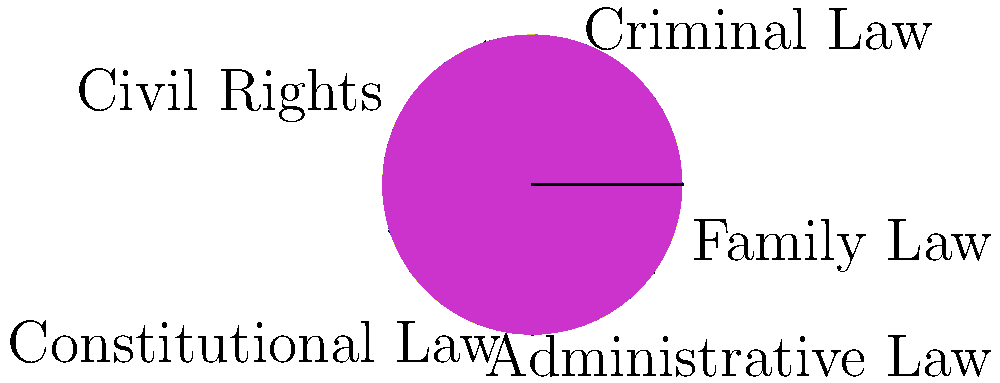Based on the pie chart depicting a judge's decisions across various legal domains, which area of law accounts for the largest portion of the judge's rulings, and what percentage does it represent? To answer this question, we need to analyze the pie chart and follow these steps:

1. Identify all the legal domains represented in the chart:
   - Criminal Law
   - Civil Rights
   - Constitutional Law
   - Administrative Law
   - Family Law

2. Visually compare the sizes of the slices to determine the largest one:
   The red slice, which represents Criminal Law, appears to be the largest.

3. Estimate the percentage of the largest slice:
   The pie chart is divided into 5 slices, with the largest (red) slice appearing to cover slightly less than one-third of the circle.

4. Calculate the exact percentage:
   The question provides the exact percentages in the data array:
   $${30, 25, 20, 15, 10}$$
   The largest value is 30, which corresponds to Criminal Law.

5. Confirm the result:
   Criminal Law accounts for 30% of the judge's decisions, which is indeed the largest portion among all legal domains represented.
Answer: Criminal Law, 30% 